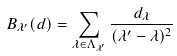Convert formula to latex. <formula><loc_0><loc_0><loc_500><loc_500>B _ { \lambda ^ { \prime } } ( d ) = \sum _ { \lambda \in \Lambda _ { \lambda ^ { \prime } } } \frac { d _ { \lambda } } { ( \lambda ^ { \prime } - \lambda ) ^ { 2 } }</formula> 